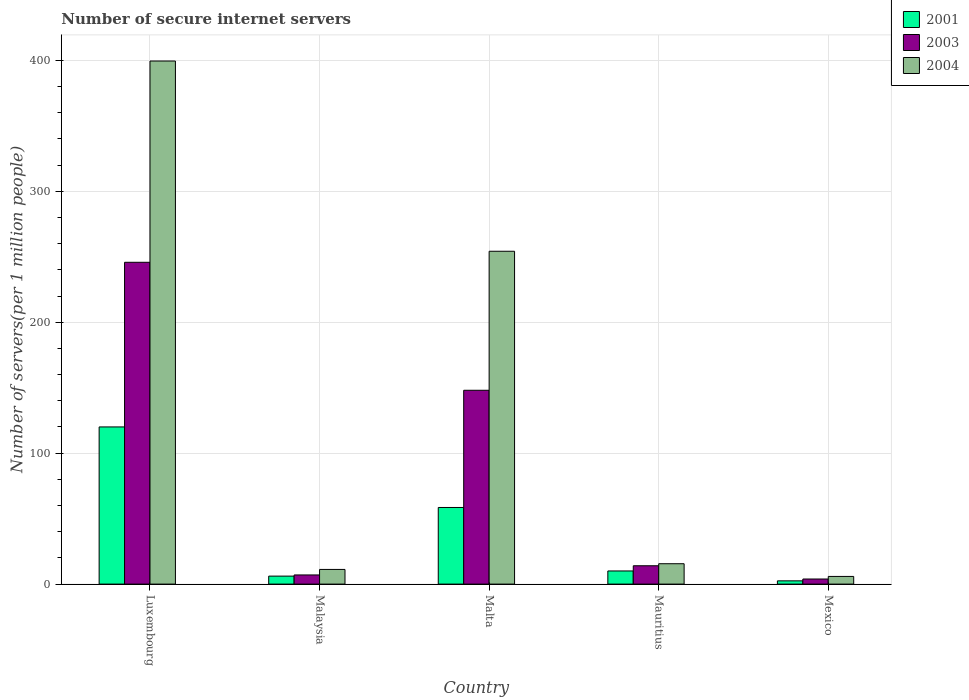How many different coloured bars are there?
Your answer should be very brief. 3. Are the number of bars per tick equal to the number of legend labels?
Your response must be concise. Yes. Are the number of bars on each tick of the X-axis equal?
Keep it short and to the point. Yes. How many bars are there on the 1st tick from the left?
Your answer should be very brief. 3. What is the label of the 4th group of bars from the left?
Keep it short and to the point. Mauritius. In how many cases, is the number of bars for a given country not equal to the number of legend labels?
Your response must be concise. 0. What is the number of secure internet servers in 2004 in Mexico?
Give a very brief answer. 5.86. Across all countries, what is the maximum number of secure internet servers in 2004?
Give a very brief answer. 399.48. Across all countries, what is the minimum number of secure internet servers in 2004?
Your answer should be very brief. 5.86. In which country was the number of secure internet servers in 2003 maximum?
Your answer should be compact. Luxembourg. In which country was the number of secure internet servers in 2003 minimum?
Your answer should be very brief. Mexico. What is the total number of secure internet servers in 2003 in the graph?
Provide a succinct answer. 418.7. What is the difference between the number of secure internet servers in 2003 in Malaysia and that in Mexico?
Ensure brevity in your answer.  3.1. What is the difference between the number of secure internet servers in 2004 in Mexico and the number of secure internet servers in 2001 in Luxembourg?
Your answer should be compact. -114.18. What is the average number of secure internet servers in 2003 per country?
Provide a short and direct response. 83.74. What is the difference between the number of secure internet servers of/in 2004 and number of secure internet servers of/in 2003 in Mauritius?
Give a very brief answer. 1.55. In how many countries, is the number of secure internet servers in 2003 greater than 360?
Your answer should be very brief. 0. What is the ratio of the number of secure internet servers in 2003 in Luxembourg to that in Mexico?
Ensure brevity in your answer.  63.15. Is the number of secure internet servers in 2003 in Luxembourg less than that in Malta?
Provide a short and direct response. No. Is the difference between the number of secure internet servers in 2004 in Malta and Mexico greater than the difference between the number of secure internet servers in 2003 in Malta and Mexico?
Offer a very short reply. Yes. What is the difference between the highest and the second highest number of secure internet servers in 2001?
Offer a terse response. 61.52. What is the difference between the highest and the lowest number of secure internet servers in 2004?
Your answer should be compact. 393.62. Is the sum of the number of secure internet servers in 2004 in Malaysia and Malta greater than the maximum number of secure internet servers in 2003 across all countries?
Give a very brief answer. Yes. What does the 1st bar from the right in Malta represents?
Your answer should be very brief. 2004. Is it the case that in every country, the sum of the number of secure internet servers in 2003 and number of secure internet servers in 2001 is greater than the number of secure internet servers in 2004?
Your answer should be very brief. No. How many countries are there in the graph?
Your response must be concise. 5. Are the values on the major ticks of Y-axis written in scientific E-notation?
Your answer should be very brief. No. Where does the legend appear in the graph?
Provide a short and direct response. Top right. What is the title of the graph?
Provide a short and direct response. Number of secure internet servers. Does "1961" appear as one of the legend labels in the graph?
Provide a short and direct response. No. What is the label or title of the X-axis?
Offer a terse response. Country. What is the label or title of the Y-axis?
Give a very brief answer. Number of servers(per 1 million people). What is the Number of servers(per 1 million people) in 2001 in Luxembourg?
Keep it short and to the point. 120.04. What is the Number of servers(per 1 million people) of 2003 in Luxembourg?
Your response must be concise. 245.78. What is the Number of servers(per 1 million people) of 2004 in Luxembourg?
Provide a short and direct response. 399.48. What is the Number of servers(per 1 million people) of 2001 in Malaysia?
Ensure brevity in your answer.  6.1. What is the Number of servers(per 1 million people) of 2003 in Malaysia?
Keep it short and to the point. 7. What is the Number of servers(per 1 million people) in 2004 in Malaysia?
Keep it short and to the point. 11.21. What is the Number of servers(per 1 million people) of 2001 in Malta?
Ensure brevity in your answer.  58.52. What is the Number of servers(per 1 million people) of 2003 in Malta?
Your response must be concise. 148.02. What is the Number of servers(per 1 million people) of 2004 in Malta?
Make the answer very short. 254.19. What is the Number of servers(per 1 million people) in 2001 in Mauritius?
Offer a very short reply. 10.03. What is the Number of servers(per 1 million people) in 2003 in Mauritius?
Your response must be concise. 14.01. What is the Number of servers(per 1 million people) of 2004 in Mauritius?
Give a very brief answer. 15.56. What is the Number of servers(per 1 million people) in 2001 in Mexico?
Provide a succinct answer. 2.48. What is the Number of servers(per 1 million people) of 2003 in Mexico?
Give a very brief answer. 3.89. What is the Number of servers(per 1 million people) of 2004 in Mexico?
Ensure brevity in your answer.  5.86. Across all countries, what is the maximum Number of servers(per 1 million people) of 2001?
Give a very brief answer. 120.04. Across all countries, what is the maximum Number of servers(per 1 million people) of 2003?
Give a very brief answer. 245.78. Across all countries, what is the maximum Number of servers(per 1 million people) of 2004?
Provide a succinct answer. 399.48. Across all countries, what is the minimum Number of servers(per 1 million people) in 2001?
Provide a succinct answer. 2.48. Across all countries, what is the minimum Number of servers(per 1 million people) in 2003?
Give a very brief answer. 3.89. Across all countries, what is the minimum Number of servers(per 1 million people) in 2004?
Provide a succinct answer. 5.86. What is the total Number of servers(per 1 million people) of 2001 in the graph?
Offer a very short reply. 197.18. What is the total Number of servers(per 1 million people) of 2003 in the graph?
Your answer should be very brief. 418.7. What is the total Number of servers(per 1 million people) of 2004 in the graph?
Keep it short and to the point. 686.3. What is the difference between the Number of servers(per 1 million people) in 2001 in Luxembourg and that in Malaysia?
Keep it short and to the point. 113.94. What is the difference between the Number of servers(per 1 million people) of 2003 in Luxembourg and that in Malaysia?
Give a very brief answer. 238.78. What is the difference between the Number of servers(per 1 million people) in 2004 in Luxembourg and that in Malaysia?
Your answer should be compact. 388.27. What is the difference between the Number of servers(per 1 million people) in 2001 in Luxembourg and that in Malta?
Your answer should be compact. 61.52. What is the difference between the Number of servers(per 1 million people) in 2003 in Luxembourg and that in Malta?
Make the answer very short. 97.75. What is the difference between the Number of servers(per 1 million people) in 2004 in Luxembourg and that in Malta?
Give a very brief answer. 145.29. What is the difference between the Number of servers(per 1 million people) of 2001 in Luxembourg and that in Mauritius?
Ensure brevity in your answer.  110.01. What is the difference between the Number of servers(per 1 million people) in 2003 in Luxembourg and that in Mauritius?
Provide a succinct answer. 231.77. What is the difference between the Number of servers(per 1 million people) of 2004 in Luxembourg and that in Mauritius?
Provide a succinct answer. 383.92. What is the difference between the Number of servers(per 1 million people) in 2001 in Luxembourg and that in Mexico?
Your answer should be very brief. 117.55. What is the difference between the Number of servers(per 1 million people) of 2003 in Luxembourg and that in Mexico?
Your response must be concise. 241.88. What is the difference between the Number of servers(per 1 million people) in 2004 in Luxembourg and that in Mexico?
Make the answer very short. 393.62. What is the difference between the Number of servers(per 1 million people) in 2001 in Malaysia and that in Malta?
Provide a succinct answer. -52.42. What is the difference between the Number of servers(per 1 million people) in 2003 in Malaysia and that in Malta?
Your answer should be compact. -141.03. What is the difference between the Number of servers(per 1 million people) of 2004 in Malaysia and that in Malta?
Your answer should be very brief. -242.98. What is the difference between the Number of servers(per 1 million people) of 2001 in Malaysia and that in Mauritius?
Keep it short and to the point. -3.93. What is the difference between the Number of servers(per 1 million people) in 2003 in Malaysia and that in Mauritius?
Your answer should be very brief. -7.01. What is the difference between the Number of servers(per 1 million people) in 2004 in Malaysia and that in Mauritius?
Ensure brevity in your answer.  -4.35. What is the difference between the Number of servers(per 1 million people) in 2001 in Malaysia and that in Mexico?
Provide a succinct answer. 3.62. What is the difference between the Number of servers(per 1 million people) of 2003 in Malaysia and that in Mexico?
Ensure brevity in your answer.  3.1. What is the difference between the Number of servers(per 1 million people) of 2004 in Malaysia and that in Mexico?
Your response must be concise. 5.35. What is the difference between the Number of servers(per 1 million people) of 2001 in Malta and that in Mauritius?
Give a very brief answer. 48.49. What is the difference between the Number of servers(per 1 million people) in 2003 in Malta and that in Mauritius?
Make the answer very short. 134.01. What is the difference between the Number of servers(per 1 million people) in 2004 in Malta and that in Mauritius?
Make the answer very short. 238.63. What is the difference between the Number of servers(per 1 million people) of 2001 in Malta and that in Mexico?
Your response must be concise. 56.04. What is the difference between the Number of servers(per 1 million people) of 2003 in Malta and that in Mexico?
Provide a short and direct response. 144.13. What is the difference between the Number of servers(per 1 million people) in 2004 in Malta and that in Mexico?
Make the answer very short. 248.34. What is the difference between the Number of servers(per 1 million people) of 2001 in Mauritius and that in Mexico?
Your response must be concise. 7.55. What is the difference between the Number of servers(per 1 million people) in 2003 in Mauritius and that in Mexico?
Offer a terse response. 10.12. What is the difference between the Number of servers(per 1 million people) in 2004 in Mauritius and that in Mexico?
Offer a terse response. 9.7. What is the difference between the Number of servers(per 1 million people) in 2001 in Luxembourg and the Number of servers(per 1 million people) in 2003 in Malaysia?
Offer a very short reply. 113.04. What is the difference between the Number of servers(per 1 million people) of 2001 in Luxembourg and the Number of servers(per 1 million people) of 2004 in Malaysia?
Your response must be concise. 108.83. What is the difference between the Number of servers(per 1 million people) in 2003 in Luxembourg and the Number of servers(per 1 million people) in 2004 in Malaysia?
Offer a very short reply. 234.57. What is the difference between the Number of servers(per 1 million people) in 2001 in Luxembourg and the Number of servers(per 1 million people) in 2003 in Malta?
Give a very brief answer. -27.99. What is the difference between the Number of servers(per 1 million people) in 2001 in Luxembourg and the Number of servers(per 1 million people) in 2004 in Malta?
Provide a short and direct response. -134.16. What is the difference between the Number of servers(per 1 million people) of 2003 in Luxembourg and the Number of servers(per 1 million people) of 2004 in Malta?
Provide a succinct answer. -8.42. What is the difference between the Number of servers(per 1 million people) in 2001 in Luxembourg and the Number of servers(per 1 million people) in 2003 in Mauritius?
Your response must be concise. 106.03. What is the difference between the Number of servers(per 1 million people) of 2001 in Luxembourg and the Number of servers(per 1 million people) of 2004 in Mauritius?
Provide a succinct answer. 104.48. What is the difference between the Number of servers(per 1 million people) of 2003 in Luxembourg and the Number of servers(per 1 million people) of 2004 in Mauritius?
Give a very brief answer. 230.22. What is the difference between the Number of servers(per 1 million people) in 2001 in Luxembourg and the Number of servers(per 1 million people) in 2003 in Mexico?
Give a very brief answer. 116.15. What is the difference between the Number of servers(per 1 million people) in 2001 in Luxembourg and the Number of servers(per 1 million people) in 2004 in Mexico?
Your response must be concise. 114.18. What is the difference between the Number of servers(per 1 million people) in 2003 in Luxembourg and the Number of servers(per 1 million people) in 2004 in Mexico?
Your answer should be very brief. 239.92. What is the difference between the Number of servers(per 1 million people) of 2001 in Malaysia and the Number of servers(per 1 million people) of 2003 in Malta?
Give a very brief answer. -141.92. What is the difference between the Number of servers(per 1 million people) in 2001 in Malaysia and the Number of servers(per 1 million people) in 2004 in Malta?
Ensure brevity in your answer.  -248.09. What is the difference between the Number of servers(per 1 million people) of 2003 in Malaysia and the Number of servers(per 1 million people) of 2004 in Malta?
Ensure brevity in your answer.  -247.2. What is the difference between the Number of servers(per 1 million people) in 2001 in Malaysia and the Number of servers(per 1 million people) in 2003 in Mauritius?
Ensure brevity in your answer.  -7.91. What is the difference between the Number of servers(per 1 million people) of 2001 in Malaysia and the Number of servers(per 1 million people) of 2004 in Mauritius?
Your answer should be compact. -9.46. What is the difference between the Number of servers(per 1 million people) in 2003 in Malaysia and the Number of servers(per 1 million people) in 2004 in Mauritius?
Make the answer very short. -8.56. What is the difference between the Number of servers(per 1 million people) of 2001 in Malaysia and the Number of servers(per 1 million people) of 2003 in Mexico?
Offer a terse response. 2.21. What is the difference between the Number of servers(per 1 million people) in 2001 in Malaysia and the Number of servers(per 1 million people) in 2004 in Mexico?
Provide a succinct answer. 0.25. What is the difference between the Number of servers(per 1 million people) in 2003 in Malaysia and the Number of servers(per 1 million people) in 2004 in Mexico?
Keep it short and to the point. 1.14. What is the difference between the Number of servers(per 1 million people) in 2001 in Malta and the Number of servers(per 1 million people) in 2003 in Mauritius?
Give a very brief answer. 44.51. What is the difference between the Number of servers(per 1 million people) in 2001 in Malta and the Number of servers(per 1 million people) in 2004 in Mauritius?
Make the answer very short. 42.96. What is the difference between the Number of servers(per 1 million people) in 2003 in Malta and the Number of servers(per 1 million people) in 2004 in Mauritius?
Your response must be concise. 132.46. What is the difference between the Number of servers(per 1 million people) in 2001 in Malta and the Number of servers(per 1 million people) in 2003 in Mexico?
Your response must be concise. 54.63. What is the difference between the Number of servers(per 1 million people) in 2001 in Malta and the Number of servers(per 1 million people) in 2004 in Mexico?
Your answer should be very brief. 52.66. What is the difference between the Number of servers(per 1 million people) of 2003 in Malta and the Number of servers(per 1 million people) of 2004 in Mexico?
Give a very brief answer. 142.17. What is the difference between the Number of servers(per 1 million people) of 2001 in Mauritius and the Number of servers(per 1 million people) of 2003 in Mexico?
Offer a very short reply. 6.14. What is the difference between the Number of servers(per 1 million people) in 2001 in Mauritius and the Number of servers(per 1 million people) in 2004 in Mexico?
Keep it short and to the point. 4.17. What is the difference between the Number of servers(per 1 million people) in 2003 in Mauritius and the Number of servers(per 1 million people) in 2004 in Mexico?
Ensure brevity in your answer.  8.15. What is the average Number of servers(per 1 million people) of 2001 per country?
Provide a succinct answer. 39.44. What is the average Number of servers(per 1 million people) of 2003 per country?
Offer a terse response. 83.74. What is the average Number of servers(per 1 million people) of 2004 per country?
Your answer should be compact. 137.26. What is the difference between the Number of servers(per 1 million people) in 2001 and Number of servers(per 1 million people) in 2003 in Luxembourg?
Ensure brevity in your answer.  -125.74. What is the difference between the Number of servers(per 1 million people) in 2001 and Number of servers(per 1 million people) in 2004 in Luxembourg?
Make the answer very short. -279.44. What is the difference between the Number of servers(per 1 million people) in 2003 and Number of servers(per 1 million people) in 2004 in Luxembourg?
Provide a succinct answer. -153.7. What is the difference between the Number of servers(per 1 million people) of 2001 and Number of servers(per 1 million people) of 2003 in Malaysia?
Provide a short and direct response. -0.89. What is the difference between the Number of servers(per 1 million people) in 2001 and Number of servers(per 1 million people) in 2004 in Malaysia?
Your answer should be very brief. -5.11. What is the difference between the Number of servers(per 1 million people) of 2003 and Number of servers(per 1 million people) of 2004 in Malaysia?
Make the answer very short. -4.21. What is the difference between the Number of servers(per 1 million people) in 2001 and Number of servers(per 1 million people) in 2003 in Malta?
Your answer should be very brief. -89.5. What is the difference between the Number of servers(per 1 million people) of 2001 and Number of servers(per 1 million people) of 2004 in Malta?
Your answer should be compact. -195.67. What is the difference between the Number of servers(per 1 million people) of 2003 and Number of servers(per 1 million people) of 2004 in Malta?
Make the answer very short. -106.17. What is the difference between the Number of servers(per 1 million people) in 2001 and Number of servers(per 1 million people) in 2003 in Mauritius?
Offer a very short reply. -3.98. What is the difference between the Number of servers(per 1 million people) of 2001 and Number of servers(per 1 million people) of 2004 in Mauritius?
Ensure brevity in your answer.  -5.53. What is the difference between the Number of servers(per 1 million people) of 2003 and Number of servers(per 1 million people) of 2004 in Mauritius?
Your response must be concise. -1.55. What is the difference between the Number of servers(per 1 million people) of 2001 and Number of servers(per 1 million people) of 2003 in Mexico?
Your answer should be compact. -1.41. What is the difference between the Number of servers(per 1 million people) in 2001 and Number of servers(per 1 million people) in 2004 in Mexico?
Keep it short and to the point. -3.37. What is the difference between the Number of servers(per 1 million people) of 2003 and Number of servers(per 1 million people) of 2004 in Mexico?
Your response must be concise. -1.96. What is the ratio of the Number of servers(per 1 million people) of 2001 in Luxembourg to that in Malaysia?
Offer a very short reply. 19.67. What is the ratio of the Number of servers(per 1 million people) of 2003 in Luxembourg to that in Malaysia?
Offer a terse response. 35.13. What is the ratio of the Number of servers(per 1 million people) in 2004 in Luxembourg to that in Malaysia?
Make the answer very short. 35.63. What is the ratio of the Number of servers(per 1 million people) in 2001 in Luxembourg to that in Malta?
Offer a very short reply. 2.05. What is the ratio of the Number of servers(per 1 million people) of 2003 in Luxembourg to that in Malta?
Your answer should be compact. 1.66. What is the ratio of the Number of servers(per 1 million people) in 2004 in Luxembourg to that in Malta?
Your response must be concise. 1.57. What is the ratio of the Number of servers(per 1 million people) in 2001 in Luxembourg to that in Mauritius?
Your answer should be very brief. 11.97. What is the ratio of the Number of servers(per 1 million people) in 2003 in Luxembourg to that in Mauritius?
Make the answer very short. 17.54. What is the ratio of the Number of servers(per 1 million people) of 2004 in Luxembourg to that in Mauritius?
Ensure brevity in your answer.  25.67. What is the ratio of the Number of servers(per 1 million people) in 2001 in Luxembourg to that in Mexico?
Your answer should be compact. 48.31. What is the ratio of the Number of servers(per 1 million people) in 2003 in Luxembourg to that in Mexico?
Your answer should be compact. 63.15. What is the ratio of the Number of servers(per 1 million people) in 2004 in Luxembourg to that in Mexico?
Offer a terse response. 68.21. What is the ratio of the Number of servers(per 1 million people) of 2001 in Malaysia to that in Malta?
Your answer should be compact. 0.1. What is the ratio of the Number of servers(per 1 million people) in 2003 in Malaysia to that in Malta?
Your answer should be compact. 0.05. What is the ratio of the Number of servers(per 1 million people) in 2004 in Malaysia to that in Malta?
Offer a very short reply. 0.04. What is the ratio of the Number of servers(per 1 million people) of 2001 in Malaysia to that in Mauritius?
Your answer should be compact. 0.61. What is the ratio of the Number of servers(per 1 million people) of 2003 in Malaysia to that in Mauritius?
Keep it short and to the point. 0.5. What is the ratio of the Number of servers(per 1 million people) of 2004 in Malaysia to that in Mauritius?
Your answer should be very brief. 0.72. What is the ratio of the Number of servers(per 1 million people) of 2001 in Malaysia to that in Mexico?
Give a very brief answer. 2.46. What is the ratio of the Number of servers(per 1 million people) of 2003 in Malaysia to that in Mexico?
Offer a terse response. 1.8. What is the ratio of the Number of servers(per 1 million people) of 2004 in Malaysia to that in Mexico?
Provide a short and direct response. 1.91. What is the ratio of the Number of servers(per 1 million people) in 2001 in Malta to that in Mauritius?
Keep it short and to the point. 5.83. What is the ratio of the Number of servers(per 1 million people) in 2003 in Malta to that in Mauritius?
Ensure brevity in your answer.  10.57. What is the ratio of the Number of servers(per 1 million people) of 2004 in Malta to that in Mauritius?
Your answer should be compact. 16.34. What is the ratio of the Number of servers(per 1 million people) of 2001 in Malta to that in Mexico?
Keep it short and to the point. 23.55. What is the ratio of the Number of servers(per 1 million people) in 2003 in Malta to that in Mexico?
Ensure brevity in your answer.  38.03. What is the ratio of the Number of servers(per 1 million people) in 2004 in Malta to that in Mexico?
Ensure brevity in your answer.  43.4. What is the ratio of the Number of servers(per 1 million people) of 2001 in Mauritius to that in Mexico?
Offer a terse response. 4.04. What is the ratio of the Number of servers(per 1 million people) of 2003 in Mauritius to that in Mexico?
Offer a terse response. 3.6. What is the ratio of the Number of servers(per 1 million people) of 2004 in Mauritius to that in Mexico?
Your response must be concise. 2.66. What is the difference between the highest and the second highest Number of servers(per 1 million people) of 2001?
Offer a terse response. 61.52. What is the difference between the highest and the second highest Number of servers(per 1 million people) of 2003?
Offer a terse response. 97.75. What is the difference between the highest and the second highest Number of servers(per 1 million people) in 2004?
Offer a terse response. 145.29. What is the difference between the highest and the lowest Number of servers(per 1 million people) in 2001?
Your answer should be very brief. 117.55. What is the difference between the highest and the lowest Number of servers(per 1 million people) of 2003?
Provide a succinct answer. 241.88. What is the difference between the highest and the lowest Number of servers(per 1 million people) in 2004?
Ensure brevity in your answer.  393.62. 